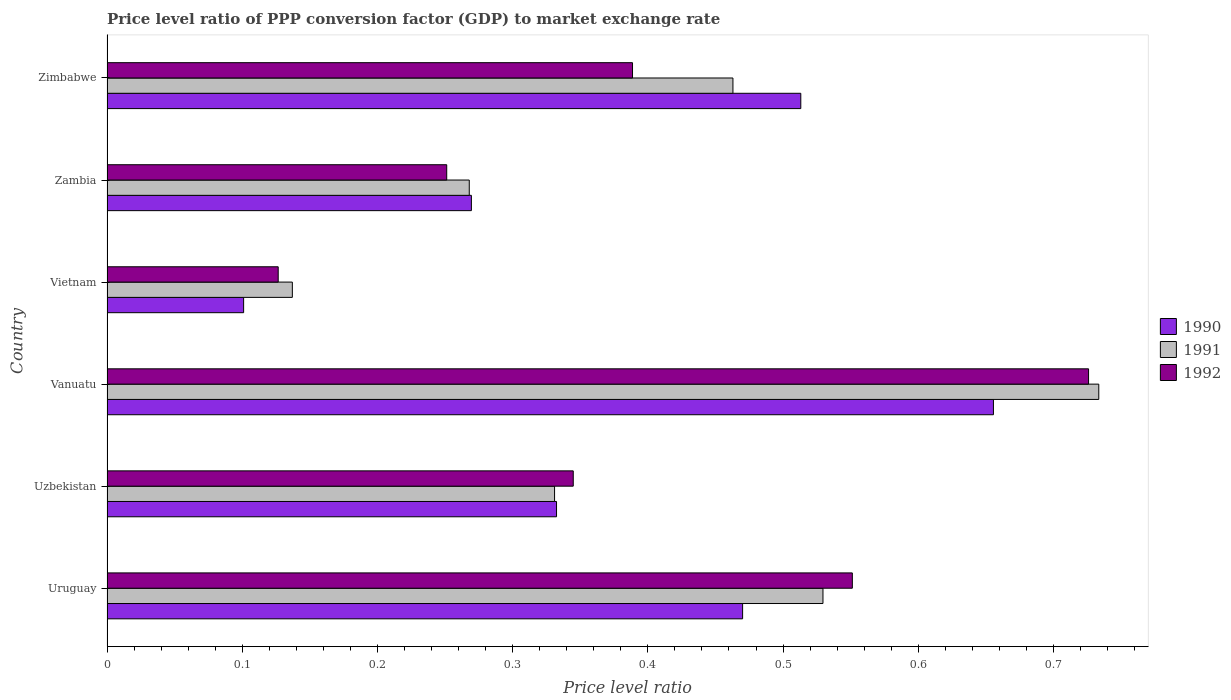How many different coloured bars are there?
Offer a terse response. 3. How many groups of bars are there?
Your response must be concise. 6. Are the number of bars per tick equal to the number of legend labels?
Your answer should be very brief. Yes. Are the number of bars on each tick of the Y-axis equal?
Make the answer very short. Yes. How many bars are there on the 3rd tick from the top?
Your response must be concise. 3. What is the label of the 4th group of bars from the top?
Your answer should be very brief. Vanuatu. In how many cases, is the number of bars for a given country not equal to the number of legend labels?
Offer a very short reply. 0. What is the price level ratio in 1992 in Zambia?
Your response must be concise. 0.25. Across all countries, what is the maximum price level ratio in 1990?
Ensure brevity in your answer.  0.66. Across all countries, what is the minimum price level ratio in 1992?
Provide a short and direct response. 0.13. In which country was the price level ratio in 1992 maximum?
Your answer should be very brief. Vanuatu. In which country was the price level ratio in 1990 minimum?
Offer a very short reply. Vietnam. What is the total price level ratio in 1990 in the graph?
Provide a short and direct response. 2.34. What is the difference between the price level ratio in 1990 in Uzbekistan and that in Vanuatu?
Offer a very short reply. -0.32. What is the difference between the price level ratio in 1990 in Zambia and the price level ratio in 1992 in Vanuatu?
Give a very brief answer. -0.46. What is the average price level ratio in 1991 per country?
Offer a terse response. 0.41. What is the difference between the price level ratio in 1991 and price level ratio in 1990 in Uruguay?
Ensure brevity in your answer.  0.06. What is the ratio of the price level ratio in 1991 in Uruguay to that in Zimbabwe?
Make the answer very short. 1.14. Is the price level ratio in 1992 in Uzbekistan less than that in Zambia?
Provide a succinct answer. No. Is the difference between the price level ratio in 1991 in Uzbekistan and Zimbabwe greater than the difference between the price level ratio in 1990 in Uzbekistan and Zimbabwe?
Keep it short and to the point. Yes. What is the difference between the highest and the second highest price level ratio in 1992?
Provide a succinct answer. 0.17. What is the difference between the highest and the lowest price level ratio in 1991?
Give a very brief answer. 0.6. In how many countries, is the price level ratio in 1990 greater than the average price level ratio in 1990 taken over all countries?
Your answer should be very brief. 3. What does the 2nd bar from the bottom in Uruguay represents?
Offer a very short reply. 1991. Is it the case that in every country, the sum of the price level ratio in 1990 and price level ratio in 1991 is greater than the price level ratio in 1992?
Make the answer very short. Yes. How many bars are there?
Your response must be concise. 18. Are all the bars in the graph horizontal?
Offer a terse response. Yes. What is the difference between two consecutive major ticks on the X-axis?
Provide a short and direct response. 0.1. Are the values on the major ticks of X-axis written in scientific E-notation?
Provide a short and direct response. No. Does the graph contain grids?
Make the answer very short. No. Where does the legend appear in the graph?
Make the answer very short. Center right. How many legend labels are there?
Offer a very short reply. 3. How are the legend labels stacked?
Keep it short and to the point. Vertical. What is the title of the graph?
Provide a succinct answer. Price level ratio of PPP conversion factor (GDP) to market exchange rate. Does "1985" appear as one of the legend labels in the graph?
Provide a short and direct response. No. What is the label or title of the X-axis?
Your response must be concise. Price level ratio. What is the label or title of the Y-axis?
Make the answer very short. Country. What is the Price level ratio in 1990 in Uruguay?
Offer a very short reply. 0.47. What is the Price level ratio of 1991 in Uruguay?
Keep it short and to the point. 0.53. What is the Price level ratio in 1992 in Uruguay?
Your response must be concise. 0.55. What is the Price level ratio in 1990 in Uzbekistan?
Ensure brevity in your answer.  0.33. What is the Price level ratio of 1991 in Uzbekistan?
Ensure brevity in your answer.  0.33. What is the Price level ratio in 1992 in Uzbekistan?
Offer a terse response. 0.34. What is the Price level ratio in 1990 in Vanuatu?
Your answer should be very brief. 0.66. What is the Price level ratio in 1991 in Vanuatu?
Offer a very short reply. 0.73. What is the Price level ratio of 1992 in Vanuatu?
Offer a very short reply. 0.73. What is the Price level ratio in 1990 in Vietnam?
Your response must be concise. 0.1. What is the Price level ratio in 1991 in Vietnam?
Offer a terse response. 0.14. What is the Price level ratio of 1992 in Vietnam?
Your response must be concise. 0.13. What is the Price level ratio in 1990 in Zambia?
Your response must be concise. 0.27. What is the Price level ratio in 1991 in Zambia?
Your response must be concise. 0.27. What is the Price level ratio in 1992 in Zambia?
Your answer should be compact. 0.25. What is the Price level ratio in 1990 in Zimbabwe?
Offer a very short reply. 0.51. What is the Price level ratio of 1991 in Zimbabwe?
Provide a short and direct response. 0.46. What is the Price level ratio in 1992 in Zimbabwe?
Offer a very short reply. 0.39. Across all countries, what is the maximum Price level ratio in 1990?
Offer a very short reply. 0.66. Across all countries, what is the maximum Price level ratio of 1991?
Offer a terse response. 0.73. Across all countries, what is the maximum Price level ratio of 1992?
Provide a short and direct response. 0.73. Across all countries, what is the minimum Price level ratio of 1990?
Your answer should be very brief. 0.1. Across all countries, what is the minimum Price level ratio of 1991?
Make the answer very short. 0.14. Across all countries, what is the minimum Price level ratio of 1992?
Keep it short and to the point. 0.13. What is the total Price level ratio of 1990 in the graph?
Offer a terse response. 2.34. What is the total Price level ratio of 1991 in the graph?
Give a very brief answer. 2.46. What is the total Price level ratio in 1992 in the graph?
Offer a very short reply. 2.39. What is the difference between the Price level ratio in 1990 in Uruguay and that in Uzbekistan?
Give a very brief answer. 0.14. What is the difference between the Price level ratio of 1991 in Uruguay and that in Uzbekistan?
Make the answer very short. 0.2. What is the difference between the Price level ratio in 1992 in Uruguay and that in Uzbekistan?
Give a very brief answer. 0.21. What is the difference between the Price level ratio of 1990 in Uruguay and that in Vanuatu?
Give a very brief answer. -0.19. What is the difference between the Price level ratio of 1991 in Uruguay and that in Vanuatu?
Your answer should be very brief. -0.2. What is the difference between the Price level ratio in 1992 in Uruguay and that in Vanuatu?
Offer a very short reply. -0.17. What is the difference between the Price level ratio in 1990 in Uruguay and that in Vietnam?
Offer a very short reply. 0.37. What is the difference between the Price level ratio of 1991 in Uruguay and that in Vietnam?
Offer a terse response. 0.39. What is the difference between the Price level ratio in 1992 in Uruguay and that in Vietnam?
Make the answer very short. 0.42. What is the difference between the Price level ratio in 1990 in Uruguay and that in Zambia?
Ensure brevity in your answer.  0.2. What is the difference between the Price level ratio in 1991 in Uruguay and that in Zambia?
Ensure brevity in your answer.  0.26. What is the difference between the Price level ratio of 1990 in Uruguay and that in Zimbabwe?
Give a very brief answer. -0.04. What is the difference between the Price level ratio in 1991 in Uruguay and that in Zimbabwe?
Ensure brevity in your answer.  0.07. What is the difference between the Price level ratio in 1992 in Uruguay and that in Zimbabwe?
Ensure brevity in your answer.  0.16. What is the difference between the Price level ratio in 1990 in Uzbekistan and that in Vanuatu?
Ensure brevity in your answer.  -0.32. What is the difference between the Price level ratio of 1991 in Uzbekistan and that in Vanuatu?
Offer a terse response. -0.4. What is the difference between the Price level ratio in 1992 in Uzbekistan and that in Vanuatu?
Your response must be concise. -0.38. What is the difference between the Price level ratio in 1990 in Uzbekistan and that in Vietnam?
Make the answer very short. 0.23. What is the difference between the Price level ratio in 1991 in Uzbekistan and that in Vietnam?
Provide a short and direct response. 0.19. What is the difference between the Price level ratio of 1992 in Uzbekistan and that in Vietnam?
Give a very brief answer. 0.22. What is the difference between the Price level ratio of 1990 in Uzbekistan and that in Zambia?
Your answer should be compact. 0.06. What is the difference between the Price level ratio of 1991 in Uzbekistan and that in Zambia?
Provide a succinct answer. 0.06. What is the difference between the Price level ratio of 1992 in Uzbekistan and that in Zambia?
Your answer should be compact. 0.09. What is the difference between the Price level ratio of 1990 in Uzbekistan and that in Zimbabwe?
Provide a succinct answer. -0.18. What is the difference between the Price level ratio in 1991 in Uzbekistan and that in Zimbabwe?
Your answer should be very brief. -0.13. What is the difference between the Price level ratio in 1992 in Uzbekistan and that in Zimbabwe?
Give a very brief answer. -0.04. What is the difference between the Price level ratio of 1990 in Vanuatu and that in Vietnam?
Your answer should be compact. 0.55. What is the difference between the Price level ratio of 1991 in Vanuatu and that in Vietnam?
Your answer should be compact. 0.6. What is the difference between the Price level ratio of 1992 in Vanuatu and that in Vietnam?
Provide a succinct answer. 0.6. What is the difference between the Price level ratio in 1990 in Vanuatu and that in Zambia?
Keep it short and to the point. 0.39. What is the difference between the Price level ratio of 1991 in Vanuatu and that in Zambia?
Ensure brevity in your answer.  0.47. What is the difference between the Price level ratio in 1992 in Vanuatu and that in Zambia?
Your answer should be compact. 0.47. What is the difference between the Price level ratio of 1990 in Vanuatu and that in Zimbabwe?
Provide a succinct answer. 0.14. What is the difference between the Price level ratio of 1991 in Vanuatu and that in Zimbabwe?
Your answer should be compact. 0.27. What is the difference between the Price level ratio of 1992 in Vanuatu and that in Zimbabwe?
Your answer should be compact. 0.34. What is the difference between the Price level ratio in 1990 in Vietnam and that in Zambia?
Provide a succinct answer. -0.17. What is the difference between the Price level ratio in 1991 in Vietnam and that in Zambia?
Your response must be concise. -0.13. What is the difference between the Price level ratio of 1992 in Vietnam and that in Zambia?
Give a very brief answer. -0.12. What is the difference between the Price level ratio in 1990 in Vietnam and that in Zimbabwe?
Your answer should be compact. -0.41. What is the difference between the Price level ratio in 1991 in Vietnam and that in Zimbabwe?
Keep it short and to the point. -0.33. What is the difference between the Price level ratio in 1992 in Vietnam and that in Zimbabwe?
Give a very brief answer. -0.26. What is the difference between the Price level ratio in 1990 in Zambia and that in Zimbabwe?
Keep it short and to the point. -0.24. What is the difference between the Price level ratio of 1991 in Zambia and that in Zimbabwe?
Provide a succinct answer. -0.2. What is the difference between the Price level ratio in 1992 in Zambia and that in Zimbabwe?
Your response must be concise. -0.14. What is the difference between the Price level ratio in 1990 in Uruguay and the Price level ratio in 1991 in Uzbekistan?
Ensure brevity in your answer.  0.14. What is the difference between the Price level ratio in 1990 in Uruguay and the Price level ratio in 1992 in Uzbekistan?
Provide a short and direct response. 0.13. What is the difference between the Price level ratio in 1991 in Uruguay and the Price level ratio in 1992 in Uzbekistan?
Give a very brief answer. 0.18. What is the difference between the Price level ratio in 1990 in Uruguay and the Price level ratio in 1991 in Vanuatu?
Provide a short and direct response. -0.26. What is the difference between the Price level ratio of 1990 in Uruguay and the Price level ratio of 1992 in Vanuatu?
Your answer should be compact. -0.26. What is the difference between the Price level ratio in 1991 in Uruguay and the Price level ratio in 1992 in Vanuatu?
Ensure brevity in your answer.  -0.2. What is the difference between the Price level ratio in 1990 in Uruguay and the Price level ratio in 1991 in Vietnam?
Keep it short and to the point. 0.33. What is the difference between the Price level ratio in 1990 in Uruguay and the Price level ratio in 1992 in Vietnam?
Give a very brief answer. 0.34. What is the difference between the Price level ratio of 1991 in Uruguay and the Price level ratio of 1992 in Vietnam?
Make the answer very short. 0.4. What is the difference between the Price level ratio in 1990 in Uruguay and the Price level ratio in 1991 in Zambia?
Your response must be concise. 0.2. What is the difference between the Price level ratio of 1990 in Uruguay and the Price level ratio of 1992 in Zambia?
Your answer should be compact. 0.22. What is the difference between the Price level ratio of 1991 in Uruguay and the Price level ratio of 1992 in Zambia?
Your answer should be very brief. 0.28. What is the difference between the Price level ratio in 1990 in Uruguay and the Price level ratio in 1991 in Zimbabwe?
Your response must be concise. 0.01. What is the difference between the Price level ratio in 1990 in Uruguay and the Price level ratio in 1992 in Zimbabwe?
Give a very brief answer. 0.08. What is the difference between the Price level ratio in 1991 in Uruguay and the Price level ratio in 1992 in Zimbabwe?
Keep it short and to the point. 0.14. What is the difference between the Price level ratio in 1990 in Uzbekistan and the Price level ratio in 1991 in Vanuatu?
Give a very brief answer. -0.4. What is the difference between the Price level ratio in 1990 in Uzbekistan and the Price level ratio in 1992 in Vanuatu?
Provide a short and direct response. -0.39. What is the difference between the Price level ratio in 1991 in Uzbekistan and the Price level ratio in 1992 in Vanuatu?
Ensure brevity in your answer.  -0.39. What is the difference between the Price level ratio in 1990 in Uzbekistan and the Price level ratio in 1991 in Vietnam?
Your response must be concise. 0.2. What is the difference between the Price level ratio of 1990 in Uzbekistan and the Price level ratio of 1992 in Vietnam?
Provide a short and direct response. 0.21. What is the difference between the Price level ratio of 1991 in Uzbekistan and the Price level ratio of 1992 in Vietnam?
Make the answer very short. 0.2. What is the difference between the Price level ratio in 1990 in Uzbekistan and the Price level ratio in 1991 in Zambia?
Provide a short and direct response. 0.06. What is the difference between the Price level ratio of 1990 in Uzbekistan and the Price level ratio of 1992 in Zambia?
Your response must be concise. 0.08. What is the difference between the Price level ratio of 1991 in Uzbekistan and the Price level ratio of 1992 in Zambia?
Your response must be concise. 0.08. What is the difference between the Price level ratio in 1990 in Uzbekistan and the Price level ratio in 1991 in Zimbabwe?
Ensure brevity in your answer.  -0.13. What is the difference between the Price level ratio of 1990 in Uzbekistan and the Price level ratio of 1992 in Zimbabwe?
Your answer should be compact. -0.06. What is the difference between the Price level ratio of 1991 in Uzbekistan and the Price level ratio of 1992 in Zimbabwe?
Provide a short and direct response. -0.06. What is the difference between the Price level ratio of 1990 in Vanuatu and the Price level ratio of 1991 in Vietnam?
Keep it short and to the point. 0.52. What is the difference between the Price level ratio in 1990 in Vanuatu and the Price level ratio in 1992 in Vietnam?
Provide a succinct answer. 0.53. What is the difference between the Price level ratio in 1991 in Vanuatu and the Price level ratio in 1992 in Vietnam?
Ensure brevity in your answer.  0.61. What is the difference between the Price level ratio of 1990 in Vanuatu and the Price level ratio of 1991 in Zambia?
Give a very brief answer. 0.39. What is the difference between the Price level ratio of 1990 in Vanuatu and the Price level ratio of 1992 in Zambia?
Your response must be concise. 0.4. What is the difference between the Price level ratio of 1991 in Vanuatu and the Price level ratio of 1992 in Zambia?
Make the answer very short. 0.48. What is the difference between the Price level ratio in 1990 in Vanuatu and the Price level ratio in 1991 in Zimbabwe?
Provide a short and direct response. 0.19. What is the difference between the Price level ratio in 1990 in Vanuatu and the Price level ratio in 1992 in Zimbabwe?
Offer a very short reply. 0.27. What is the difference between the Price level ratio of 1991 in Vanuatu and the Price level ratio of 1992 in Zimbabwe?
Your answer should be compact. 0.34. What is the difference between the Price level ratio in 1990 in Vietnam and the Price level ratio in 1991 in Zambia?
Provide a short and direct response. -0.17. What is the difference between the Price level ratio in 1990 in Vietnam and the Price level ratio in 1992 in Zambia?
Ensure brevity in your answer.  -0.15. What is the difference between the Price level ratio in 1991 in Vietnam and the Price level ratio in 1992 in Zambia?
Provide a short and direct response. -0.11. What is the difference between the Price level ratio of 1990 in Vietnam and the Price level ratio of 1991 in Zimbabwe?
Offer a terse response. -0.36. What is the difference between the Price level ratio in 1990 in Vietnam and the Price level ratio in 1992 in Zimbabwe?
Your answer should be compact. -0.29. What is the difference between the Price level ratio of 1991 in Vietnam and the Price level ratio of 1992 in Zimbabwe?
Make the answer very short. -0.25. What is the difference between the Price level ratio of 1990 in Zambia and the Price level ratio of 1991 in Zimbabwe?
Provide a succinct answer. -0.19. What is the difference between the Price level ratio of 1990 in Zambia and the Price level ratio of 1992 in Zimbabwe?
Make the answer very short. -0.12. What is the difference between the Price level ratio in 1991 in Zambia and the Price level ratio in 1992 in Zimbabwe?
Provide a short and direct response. -0.12. What is the average Price level ratio of 1990 per country?
Offer a very short reply. 0.39. What is the average Price level ratio in 1991 per country?
Offer a very short reply. 0.41. What is the average Price level ratio in 1992 per country?
Keep it short and to the point. 0.4. What is the difference between the Price level ratio in 1990 and Price level ratio in 1991 in Uruguay?
Make the answer very short. -0.06. What is the difference between the Price level ratio of 1990 and Price level ratio of 1992 in Uruguay?
Your answer should be very brief. -0.08. What is the difference between the Price level ratio in 1991 and Price level ratio in 1992 in Uruguay?
Provide a succinct answer. -0.02. What is the difference between the Price level ratio in 1990 and Price level ratio in 1991 in Uzbekistan?
Your answer should be very brief. 0. What is the difference between the Price level ratio in 1990 and Price level ratio in 1992 in Uzbekistan?
Ensure brevity in your answer.  -0.01. What is the difference between the Price level ratio of 1991 and Price level ratio of 1992 in Uzbekistan?
Offer a terse response. -0.01. What is the difference between the Price level ratio of 1990 and Price level ratio of 1991 in Vanuatu?
Your answer should be very brief. -0.08. What is the difference between the Price level ratio of 1990 and Price level ratio of 1992 in Vanuatu?
Provide a short and direct response. -0.07. What is the difference between the Price level ratio of 1991 and Price level ratio of 1992 in Vanuatu?
Provide a succinct answer. 0.01. What is the difference between the Price level ratio of 1990 and Price level ratio of 1991 in Vietnam?
Give a very brief answer. -0.04. What is the difference between the Price level ratio of 1990 and Price level ratio of 1992 in Vietnam?
Make the answer very short. -0.03. What is the difference between the Price level ratio in 1991 and Price level ratio in 1992 in Vietnam?
Offer a terse response. 0.01. What is the difference between the Price level ratio of 1990 and Price level ratio of 1991 in Zambia?
Your response must be concise. 0. What is the difference between the Price level ratio in 1990 and Price level ratio in 1992 in Zambia?
Offer a terse response. 0.02. What is the difference between the Price level ratio of 1991 and Price level ratio of 1992 in Zambia?
Your answer should be very brief. 0.02. What is the difference between the Price level ratio of 1990 and Price level ratio of 1991 in Zimbabwe?
Provide a succinct answer. 0.05. What is the difference between the Price level ratio of 1990 and Price level ratio of 1992 in Zimbabwe?
Offer a terse response. 0.12. What is the difference between the Price level ratio in 1991 and Price level ratio in 1992 in Zimbabwe?
Provide a short and direct response. 0.07. What is the ratio of the Price level ratio of 1990 in Uruguay to that in Uzbekistan?
Your response must be concise. 1.41. What is the ratio of the Price level ratio in 1991 in Uruguay to that in Uzbekistan?
Provide a succinct answer. 1.6. What is the ratio of the Price level ratio of 1992 in Uruguay to that in Uzbekistan?
Make the answer very short. 1.6. What is the ratio of the Price level ratio in 1990 in Uruguay to that in Vanuatu?
Your response must be concise. 0.72. What is the ratio of the Price level ratio in 1991 in Uruguay to that in Vanuatu?
Provide a short and direct response. 0.72. What is the ratio of the Price level ratio in 1992 in Uruguay to that in Vanuatu?
Your answer should be very brief. 0.76. What is the ratio of the Price level ratio in 1990 in Uruguay to that in Vietnam?
Give a very brief answer. 4.65. What is the ratio of the Price level ratio in 1991 in Uruguay to that in Vietnam?
Give a very brief answer. 3.86. What is the ratio of the Price level ratio of 1992 in Uruguay to that in Vietnam?
Offer a very short reply. 4.35. What is the ratio of the Price level ratio in 1990 in Uruguay to that in Zambia?
Ensure brevity in your answer.  1.74. What is the ratio of the Price level ratio of 1991 in Uruguay to that in Zambia?
Your response must be concise. 1.98. What is the ratio of the Price level ratio of 1992 in Uruguay to that in Zambia?
Make the answer very short. 2.19. What is the ratio of the Price level ratio in 1990 in Uruguay to that in Zimbabwe?
Offer a terse response. 0.92. What is the ratio of the Price level ratio in 1991 in Uruguay to that in Zimbabwe?
Ensure brevity in your answer.  1.14. What is the ratio of the Price level ratio in 1992 in Uruguay to that in Zimbabwe?
Keep it short and to the point. 1.42. What is the ratio of the Price level ratio in 1990 in Uzbekistan to that in Vanuatu?
Keep it short and to the point. 0.51. What is the ratio of the Price level ratio of 1991 in Uzbekistan to that in Vanuatu?
Your answer should be very brief. 0.45. What is the ratio of the Price level ratio in 1992 in Uzbekistan to that in Vanuatu?
Offer a very short reply. 0.47. What is the ratio of the Price level ratio in 1990 in Uzbekistan to that in Vietnam?
Give a very brief answer. 3.29. What is the ratio of the Price level ratio in 1991 in Uzbekistan to that in Vietnam?
Keep it short and to the point. 2.41. What is the ratio of the Price level ratio in 1992 in Uzbekistan to that in Vietnam?
Offer a terse response. 2.72. What is the ratio of the Price level ratio of 1990 in Uzbekistan to that in Zambia?
Your answer should be very brief. 1.23. What is the ratio of the Price level ratio of 1991 in Uzbekistan to that in Zambia?
Your answer should be compact. 1.24. What is the ratio of the Price level ratio in 1992 in Uzbekistan to that in Zambia?
Your answer should be very brief. 1.37. What is the ratio of the Price level ratio in 1990 in Uzbekistan to that in Zimbabwe?
Your answer should be very brief. 0.65. What is the ratio of the Price level ratio of 1991 in Uzbekistan to that in Zimbabwe?
Provide a short and direct response. 0.71. What is the ratio of the Price level ratio in 1992 in Uzbekistan to that in Zimbabwe?
Keep it short and to the point. 0.89. What is the ratio of the Price level ratio in 1990 in Vanuatu to that in Vietnam?
Your answer should be very brief. 6.49. What is the ratio of the Price level ratio of 1991 in Vanuatu to that in Vietnam?
Provide a short and direct response. 5.35. What is the ratio of the Price level ratio in 1992 in Vanuatu to that in Vietnam?
Ensure brevity in your answer.  5.73. What is the ratio of the Price level ratio of 1990 in Vanuatu to that in Zambia?
Keep it short and to the point. 2.43. What is the ratio of the Price level ratio in 1991 in Vanuatu to that in Zambia?
Your answer should be compact. 2.74. What is the ratio of the Price level ratio of 1992 in Vanuatu to that in Zambia?
Provide a succinct answer. 2.89. What is the ratio of the Price level ratio of 1990 in Vanuatu to that in Zimbabwe?
Ensure brevity in your answer.  1.28. What is the ratio of the Price level ratio in 1991 in Vanuatu to that in Zimbabwe?
Offer a terse response. 1.58. What is the ratio of the Price level ratio of 1992 in Vanuatu to that in Zimbabwe?
Keep it short and to the point. 1.87. What is the ratio of the Price level ratio of 1990 in Vietnam to that in Zambia?
Your answer should be compact. 0.37. What is the ratio of the Price level ratio of 1991 in Vietnam to that in Zambia?
Provide a short and direct response. 0.51. What is the ratio of the Price level ratio of 1992 in Vietnam to that in Zambia?
Keep it short and to the point. 0.5. What is the ratio of the Price level ratio in 1990 in Vietnam to that in Zimbabwe?
Keep it short and to the point. 0.2. What is the ratio of the Price level ratio in 1991 in Vietnam to that in Zimbabwe?
Your answer should be very brief. 0.3. What is the ratio of the Price level ratio of 1992 in Vietnam to that in Zimbabwe?
Provide a short and direct response. 0.33. What is the ratio of the Price level ratio in 1990 in Zambia to that in Zimbabwe?
Your answer should be compact. 0.53. What is the ratio of the Price level ratio of 1991 in Zambia to that in Zimbabwe?
Ensure brevity in your answer.  0.58. What is the ratio of the Price level ratio in 1992 in Zambia to that in Zimbabwe?
Your answer should be very brief. 0.65. What is the difference between the highest and the second highest Price level ratio of 1990?
Offer a terse response. 0.14. What is the difference between the highest and the second highest Price level ratio of 1991?
Provide a short and direct response. 0.2. What is the difference between the highest and the second highest Price level ratio of 1992?
Make the answer very short. 0.17. What is the difference between the highest and the lowest Price level ratio of 1990?
Provide a short and direct response. 0.55. What is the difference between the highest and the lowest Price level ratio in 1991?
Your answer should be very brief. 0.6. What is the difference between the highest and the lowest Price level ratio in 1992?
Provide a succinct answer. 0.6. 